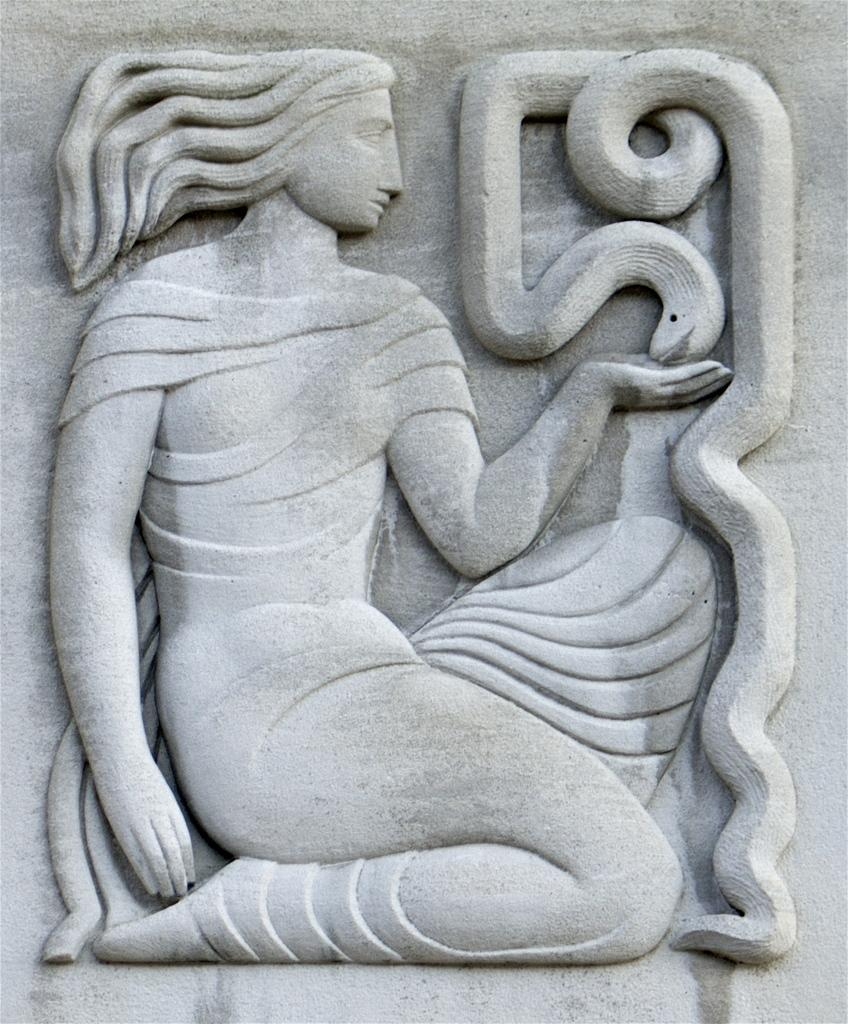What is the main subject of the image? There is a sculpture of a woman in the image. Are there any other objects or creatures in the image? Yes, there is a snake in the image. What grade does the sand receive in the image? There is no sand present in the image, so it cannot be graded. How many legs does the leg have in the image? There is no leg present in the image, so it cannot be counted. 